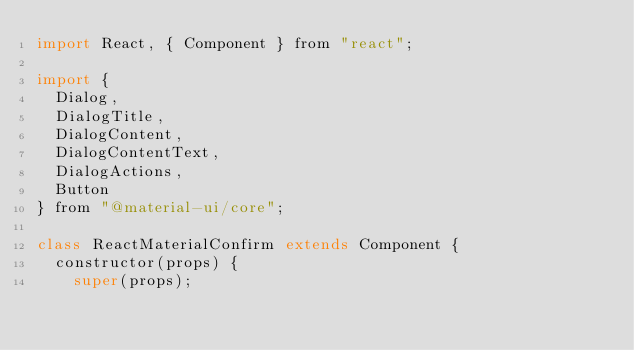<code> <loc_0><loc_0><loc_500><loc_500><_JavaScript_>import React, { Component } from "react";

import {
  Dialog,
  DialogTitle,
  DialogContent,
  DialogContentText,
  DialogActions,
  Button
} from "@material-ui/core";

class ReactMaterialConfirm extends Component {
  constructor(props) {
    super(props);</code> 